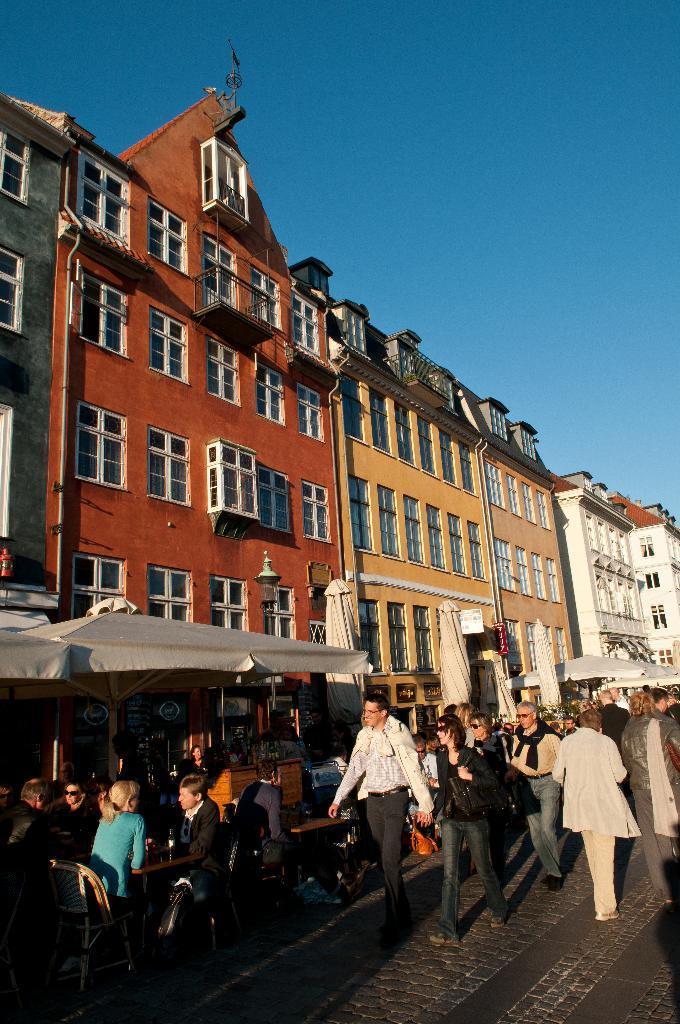Please provide a concise description of this image. In this picture I can see group of people standing, there are umbrellas, group of people sitting on the chairs, there are buildings, and in the background there is sky. 